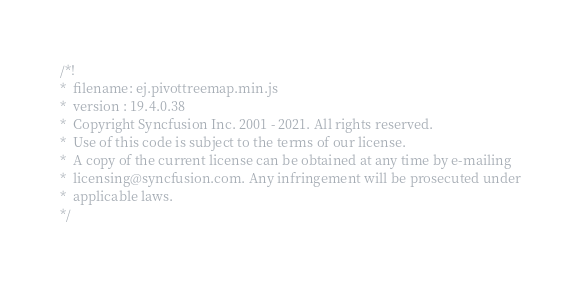Convert code to text. <code><loc_0><loc_0><loc_500><loc_500><_JavaScript_>/*!
*  filename: ej.pivottreemap.min.js
*  version : 19.4.0.38
*  Copyright Syncfusion Inc. 2001 - 2021. All rights reserved.
*  Use of this code is subject to the terms of our license.
*  A copy of the current license can be obtained at any time by e-mailing
*  licensing@syncfusion.com. Any infringement will be prosecuted under
*  applicable laws. 
*/</code> 